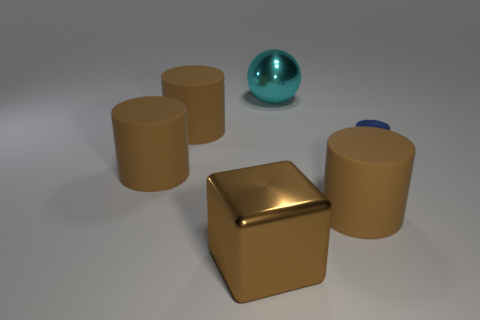Subtract all cyan balls. How many brown cylinders are left? 3 Add 2 large cyan metallic balls. How many objects exist? 8 Subtract all red cylinders. Subtract all yellow spheres. How many cylinders are left? 4 Subtract all blocks. How many objects are left? 5 Add 1 small objects. How many small objects are left? 2 Add 1 metal objects. How many metal objects exist? 4 Subtract 0 yellow cylinders. How many objects are left? 6 Subtract all small red matte cylinders. Subtract all large brown things. How many objects are left? 2 